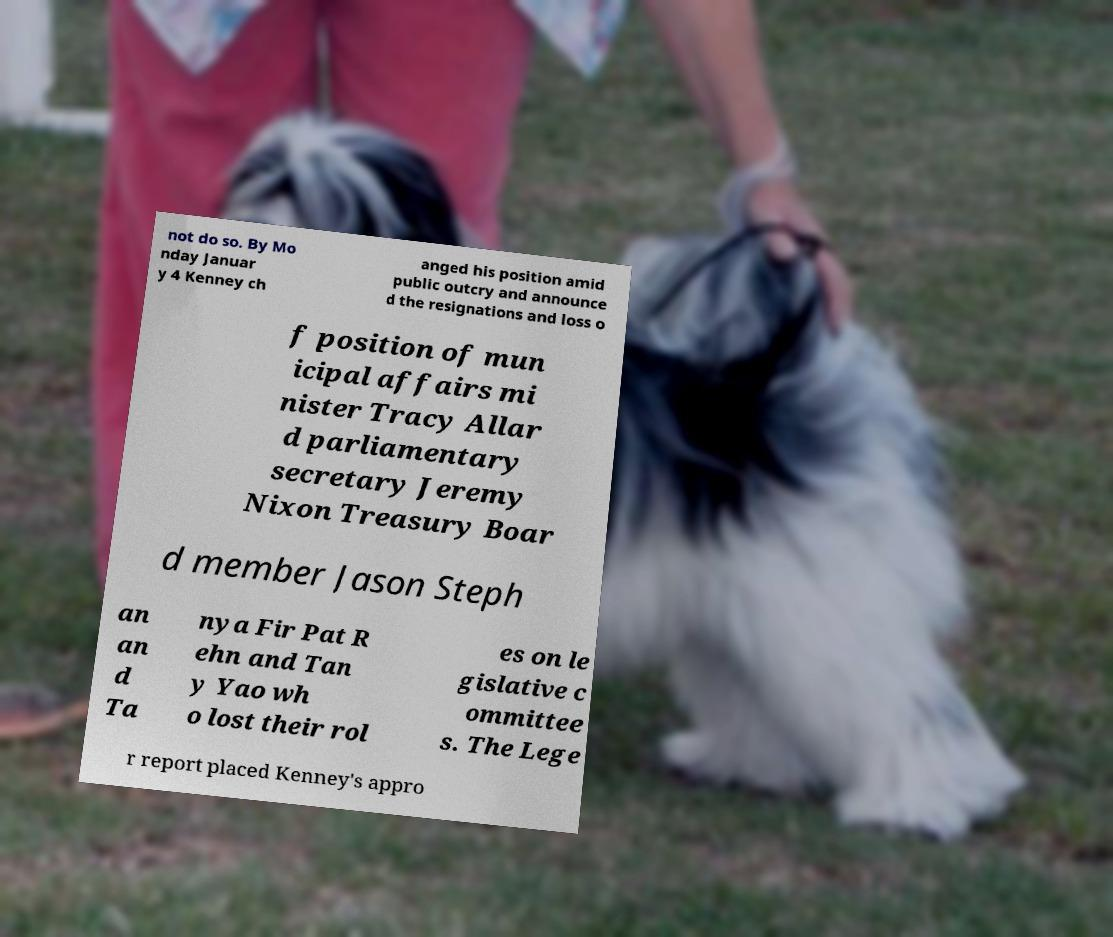Could you extract and type out the text from this image? not do so. By Mo nday Januar y 4 Kenney ch anged his position amid public outcry and announce d the resignations and loss o f position of mun icipal affairs mi nister Tracy Allar d parliamentary secretary Jeremy Nixon Treasury Boar d member Jason Steph an an d Ta nya Fir Pat R ehn and Tan y Yao wh o lost their rol es on le gislative c ommittee s. The Lege r report placed Kenney's appro 